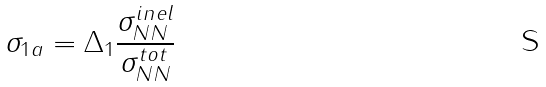<formula> <loc_0><loc_0><loc_500><loc_500>\sigma _ { 1 a } = \Delta _ { 1 } \frac { \sigma _ { N N } ^ { i n e l } } { \sigma _ { N N } ^ { t o t } }</formula> 